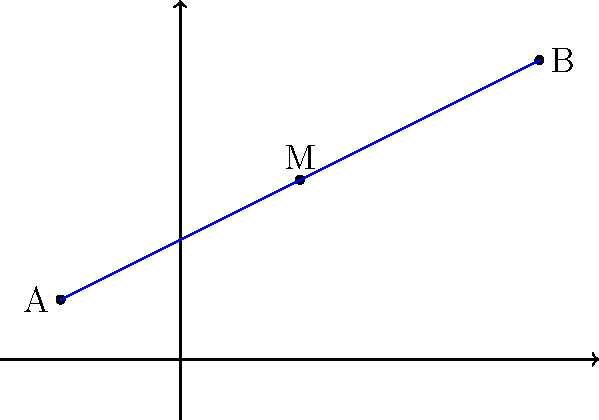As an author, you're writing a scene where a character needs to find the exact center of a line connecting two plot points on a map. Given that one end of the line is at coordinates $(-2, 1)$ and the other end is at $(6, 5)$, what are the coordinates of the midpoint? Round your answer to one decimal place if necessary. To find the midpoint of a line segment, we can use the midpoint formula:

$$ M_x = \frac{x_1 + x_2}{2}, \quad M_y = \frac{y_1 + y_2}{2} $$

Where $(x_1, y_1)$ and $(x_2, y_2)$ are the coordinates of the endpoints.

Step 1: Identify the coordinates
- Point A: $(-2, 1)$
- Point B: $(6, 5)$

Step 2: Calculate the x-coordinate of the midpoint
$$ M_x = \frac{-2 + 6}{2} = \frac{4}{2} = 2 $$

Step 3: Calculate the y-coordinate of the midpoint
$$ M_y = \frac{1 + 5}{2} = \frac{6}{2} = 3 $$

Step 4: Combine the results
The midpoint M has coordinates $(2, 3)$.

Since both coordinates are already whole numbers, no rounding is necessary.
Answer: $(2, 3)$ 